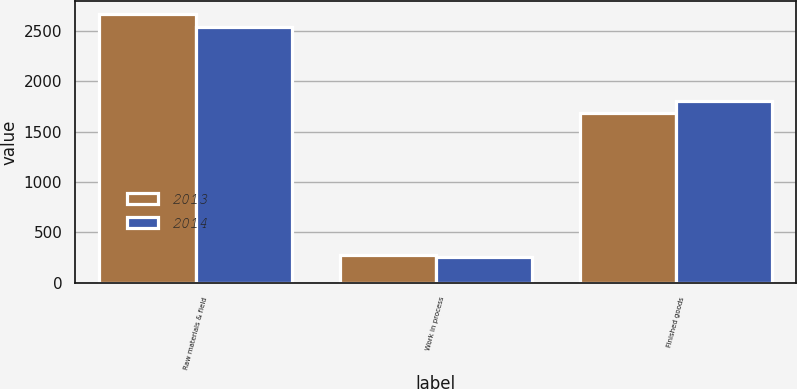<chart> <loc_0><loc_0><loc_500><loc_500><stacked_bar_chart><ecel><fcel>Raw materials & field<fcel>Work in process<fcel>Finished goods<nl><fcel>2013<fcel>2666<fcel>273<fcel>1689<nl><fcel>2014<fcel>2539<fcel>261<fcel>1803<nl></chart> 